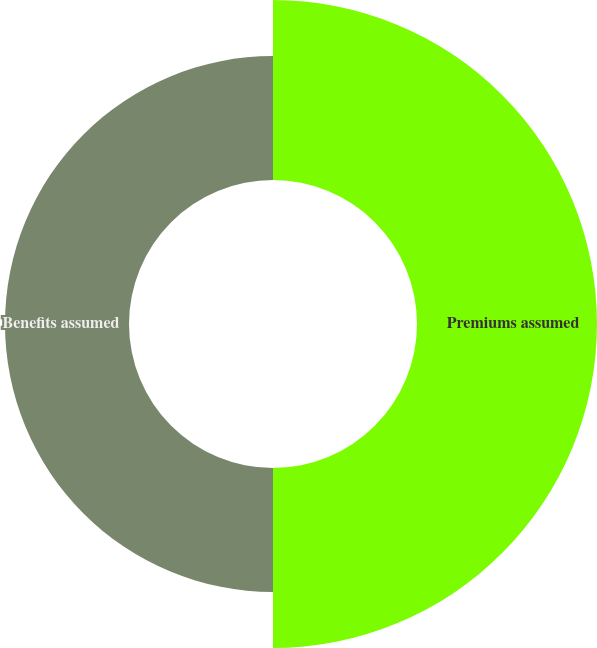<chart> <loc_0><loc_0><loc_500><loc_500><pie_chart><fcel>Premiums assumed<fcel>Benefits assumed<nl><fcel>59.21%<fcel>40.79%<nl></chart> 